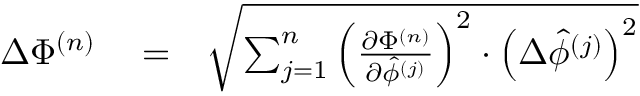<formula> <loc_0><loc_0><loc_500><loc_500>\begin{array} { r l r } { \Delta \Phi ^ { ( n ) } } & = } & { \sqrt { \sum _ { j = 1 } ^ { n } \left ( \frac { \partial \Phi ^ { ( n ) } } { \partial \hat { \phi } ^ { ( j ) } } \right ) ^ { 2 } \cdot \left ( \Delta \hat { \phi } ^ { ( j ) } \right ) ^ { 2 } } } \end{array}</formula> 